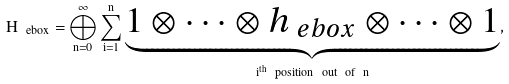Convert formula to latex. <formula><loc_0><loc_0><loc_500><loc_500>H _ { \ e b o x } = \bigoplus _ { n = 0 } ^ { \infty } \sum _ { i = 1 } ^ { n } \underbrace { 1 \otimes \cdots \otimes h _ { \ e b o x } \otimes \cdots \otimes 1 } _ { i ^ { t h } \ p o s i t i o n \ o u t \ o f \ n } ,</formula> 